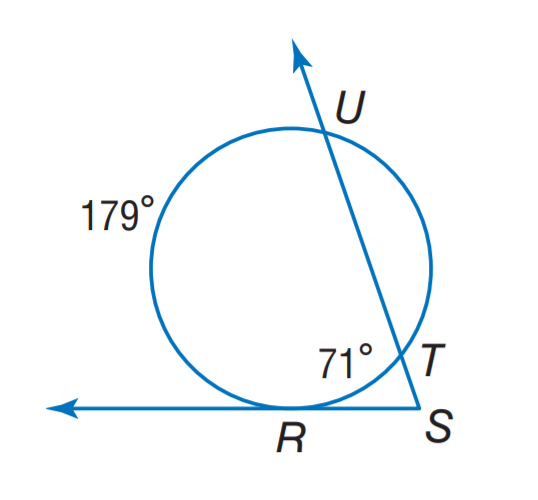Question: Find m \angle S.
Choices:
A. 27
B. 35.5
C. 54
D. 71
Answer with the letter. Answer: C 